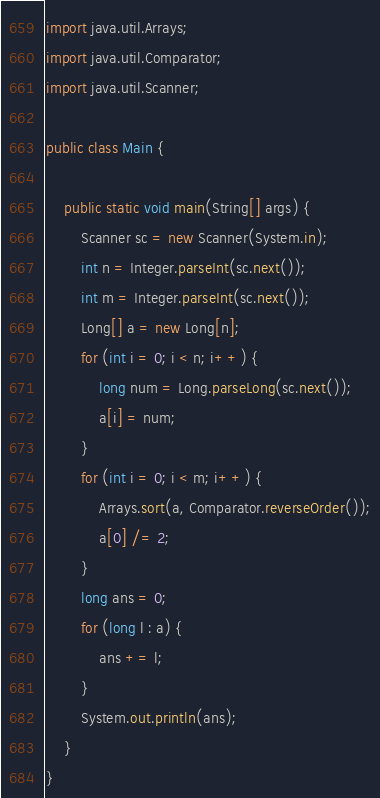<code> <loc_0><loc_0><loc_500><loc_500><_Java_>import java.util.Arrays;
import java.util.Comparator;
import java.util.Scanner;

public class Main {

    public static void main(String[] args) {
        Scanner sc = new Scanner(System.in);
        int n = Integer.parseInt(sc.next());
        int m = Integer.parseInt(sc.next());
        Long[] a = new Long[n];
        for (int i = 0; i < n; i++) {
            long num = Long.parseLong(sc.next());
            a[i] = num;
        }
        for (int i = 0; i < m; i++) {
            Arrays.sort(a, Comparator.reverseOrder());
            a[0] /= 2;
        }
        long ans = 0;
        for (long l : a) {
            ans += l;
        }
        System.out.println(ans);
    }
}</code> 